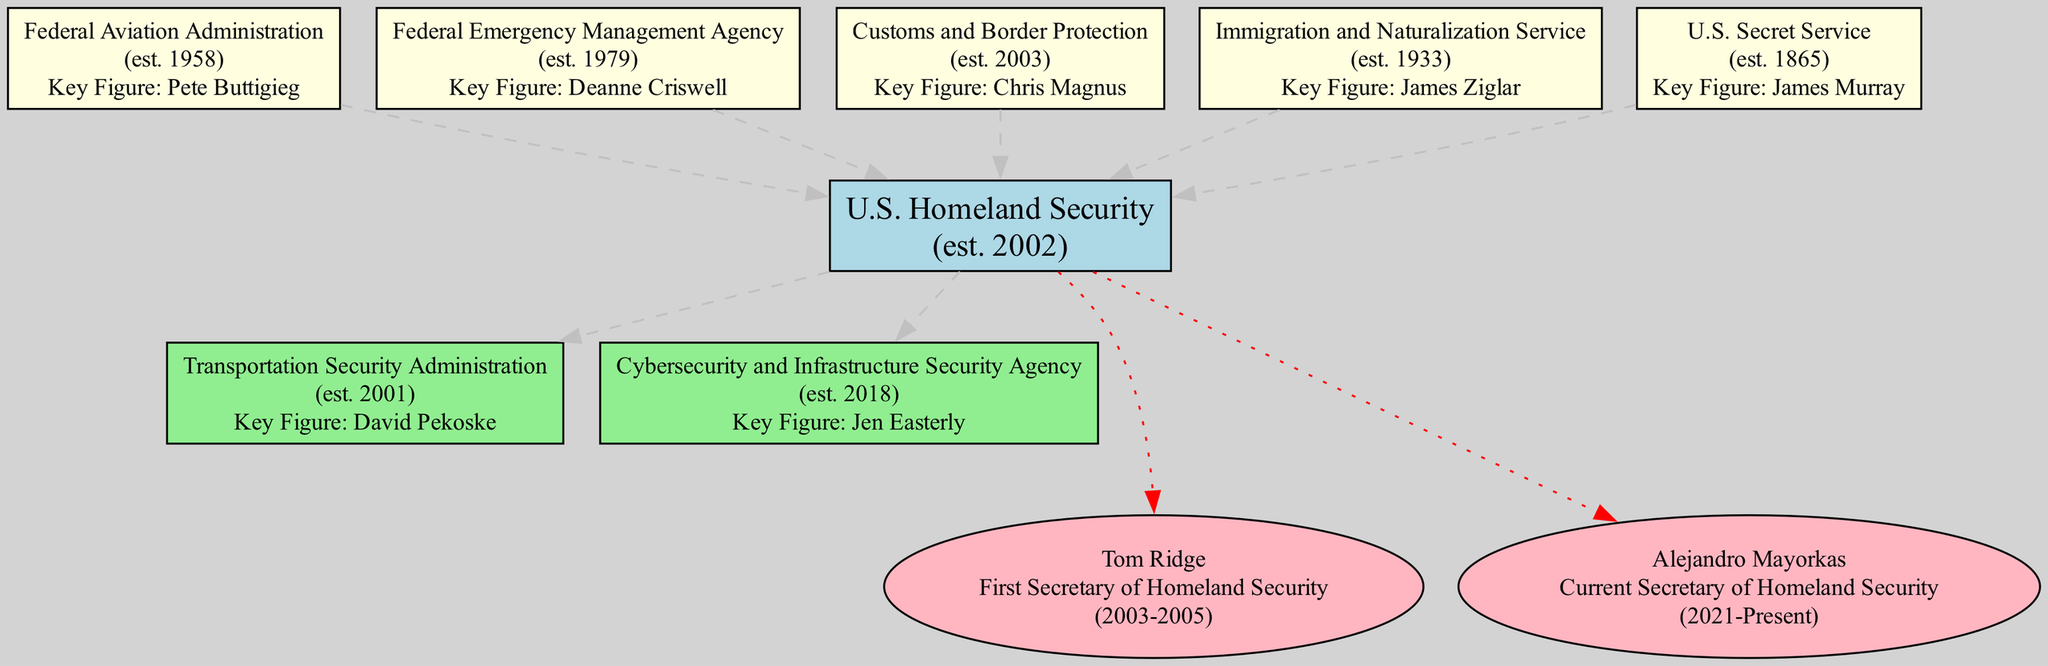What year was the U.S. Department of Homeland Security established? The diagram states that the U.S. Homeland Security was established in 2002, which is mentioned in the node that represents this agency.
Answer: 2002 Who is the current Secretary of Homeland Security? The node for key figures lists Alejandro Mayorkas as the current Secretary of Homeland Security, indicating his role and term start date.
Answer: Alejandro Mayorkas How many predecessor agencies are listed in the diagram? By counting the agencies listed under the “Predecessor Agencies” section of the diagram, it shows five agencies that preceded the U.S. Homeland Security.
Answer: 5 What is the inception year of the Federal Emergency Management Agency? The diagram provides the inception year for the Federal Emergency Management Agency as 1979, which is shown next to this agency in the predecessor section.
Answer: 1979 Which agency succeeded the Transportation Security Administration? The subsequent agencies section does not list any agencies that succeeded the Transportation Security Administration, only that it was established before the mentioned agencies. This indicates there are no direct successors.
Answer: None Who was the first Secretary of Homeland Security? The first Secretary of Homeland Security is Tom Ridge, as indicated in the diagram under the key figures section with his name and role.
Answer: Tom Ridge What color represents the predecessor agencies in the diagram? The color used for the predecessor agencies in the diagram is light yellow, as specified in the node style for these agencies.
Answer: Light yellow How many key figures are mentioned in the diagram? The diagram lists two key figures related to the Homeland Security: Tom Ridge and Alejandro Mayorkas, which are found in the key figures section.
Answer: 2 Which agency was established immediately prior to the U.S. Homeland Security? The diagram shows the Transportation Security Administration, established in 2001, as the agency immediately prior to the creation of the U.S. Homeland Security.
Answer: Transportation Security Administration 